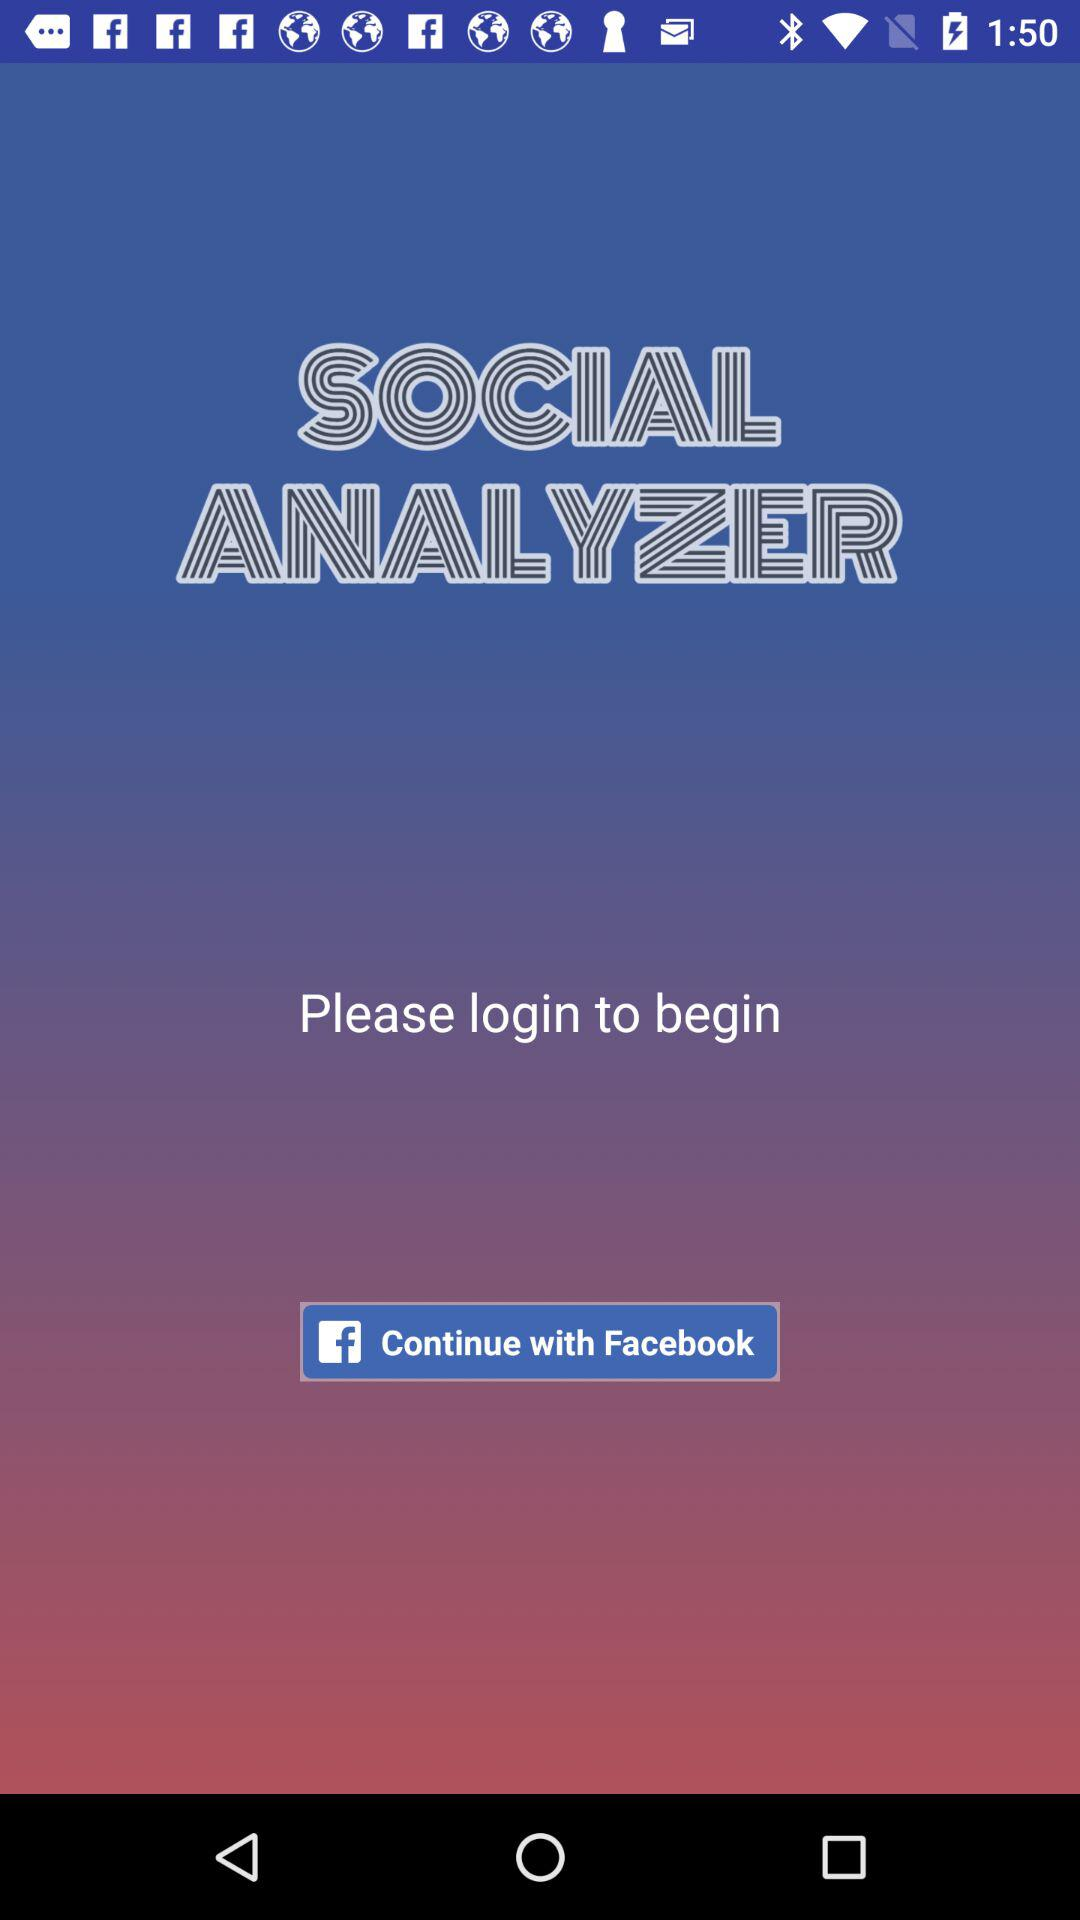What social app can we login with? You can login with "Facebook". 